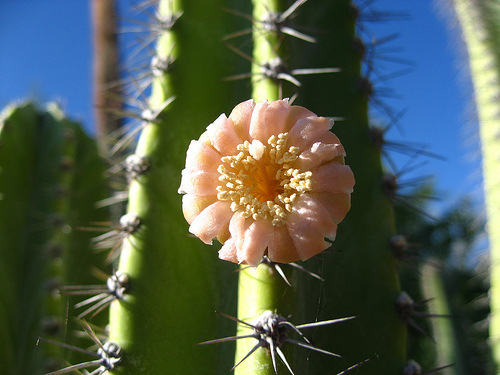<image>
Is there a flower in front of the thorn? Yes. The flower is positioned in front of the thorn, appearing closer to the camera viewpoint. 